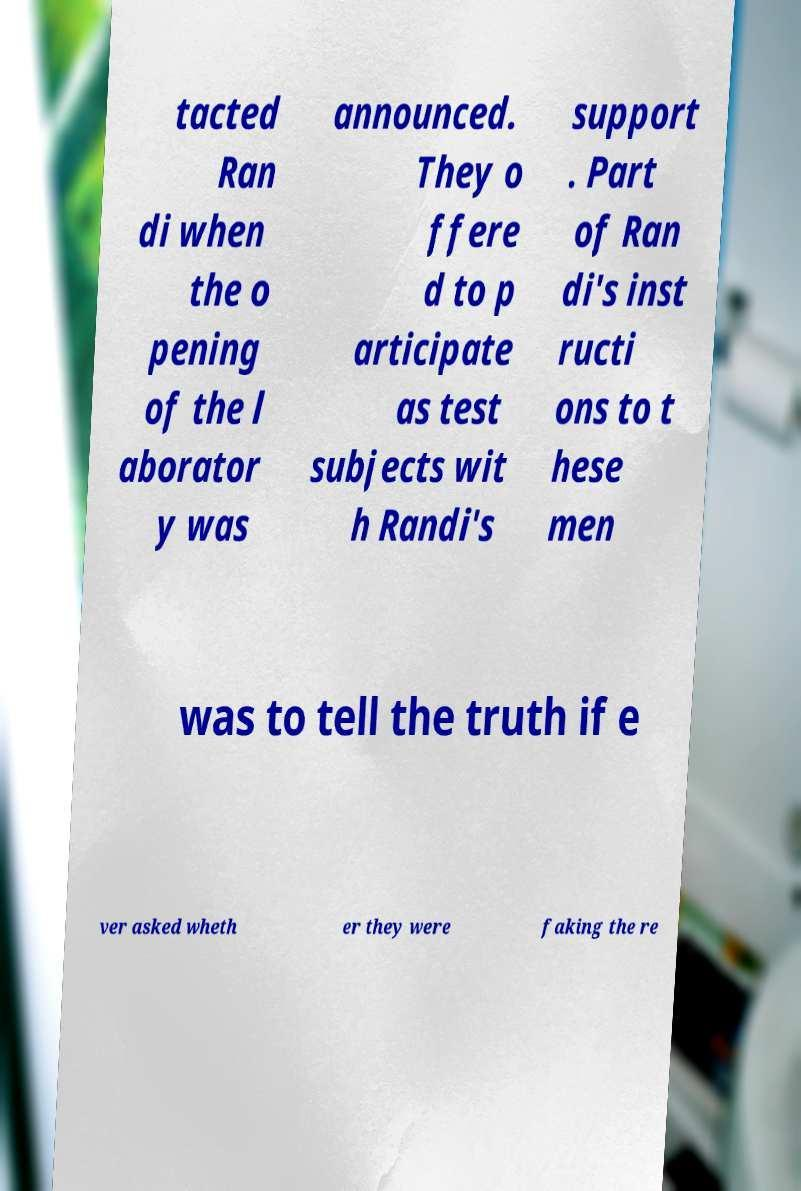Could you extract and type out the text from this image? tacted Ran di when the o pening of the l aborator y was announced. They o ffere d to p articipate as test subjects wit h Randi's support . Part of Ran di's inst ructi ons to t hese men was to tell the truth if e ver asked wheth er they were faking the re 